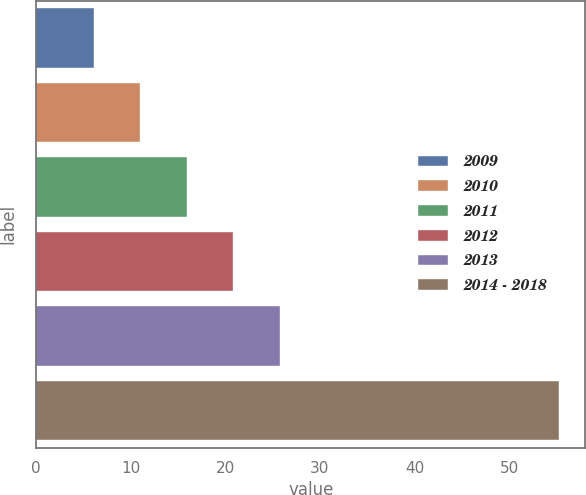<chart> <loc_0><loc_0><loc_500><loc_500><bar_chart><fcel>2009<fcel>2010<fcel>2011<fcel>2012<fcel>2013<fcel>2014 - 2018<nl><fcel>6.1<fcel>11.02<fcel>15.94<fcel>20.86<fcel>25.78<fcel>55.3<nl></chart> 